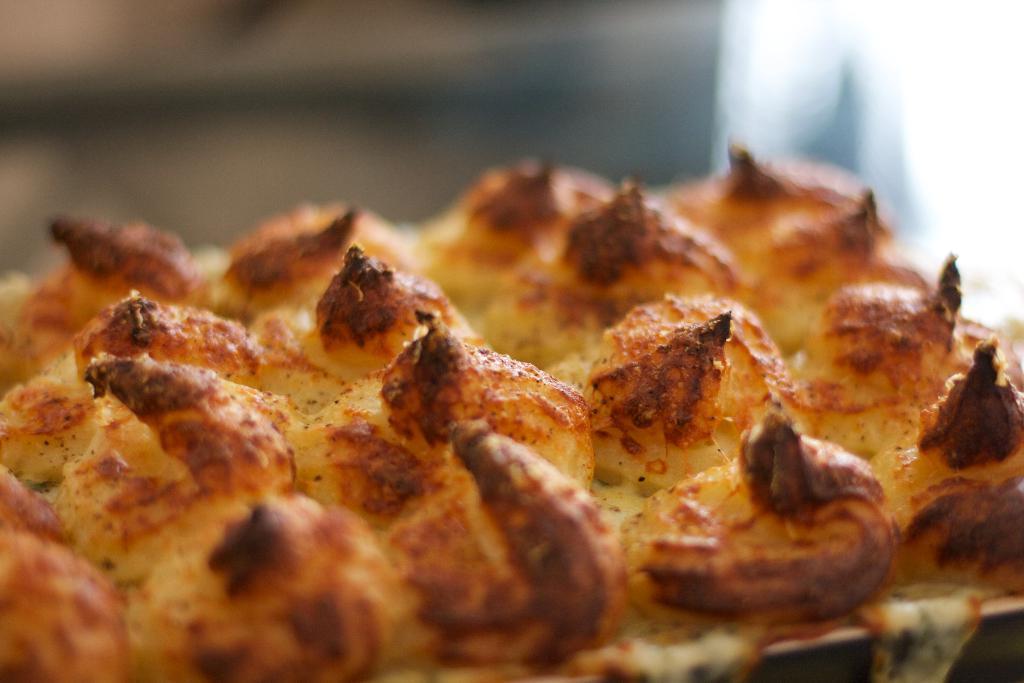Can you describe this image briefly? In the image there is a pizza and the background is blurry. 